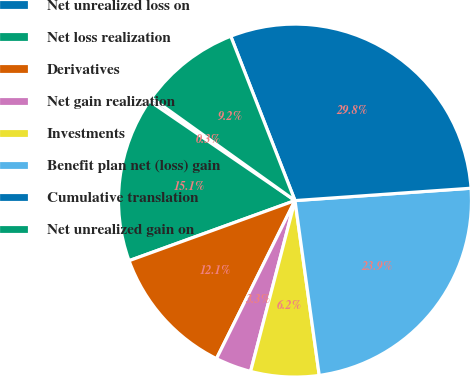Convert chart. <chart><loc_0><loc_0><loc_500><loc_500><pie_chart><fcel>Net unrealized loss on<fcel>Net loss realization<fcel>Derivatives<fcel>Net gain realization<fcel>Investments<fcel>Benefit plan net (loss) gain<fcel>Cumulative translation<fcel>Net unrealized gain on<nl><fcel>0.34%<fcel>15.08%<fcel>12.13%<fcel>3.29%<fcel>6.24%<fcel>23.92%<fcel>29.81%<fcel>9.18%<nl></chart> 